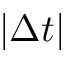Convert formula to latex. <formula><loc_0><loc_0><loc_500><loc_500>\left | \Delta t \right |</formula> 